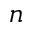<formula> <loc_0><loc_0><loc_500><loc_500>n</formula> 